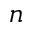<formula> <loc_0><loc_0><loc_500><loc_500>n</formula> 